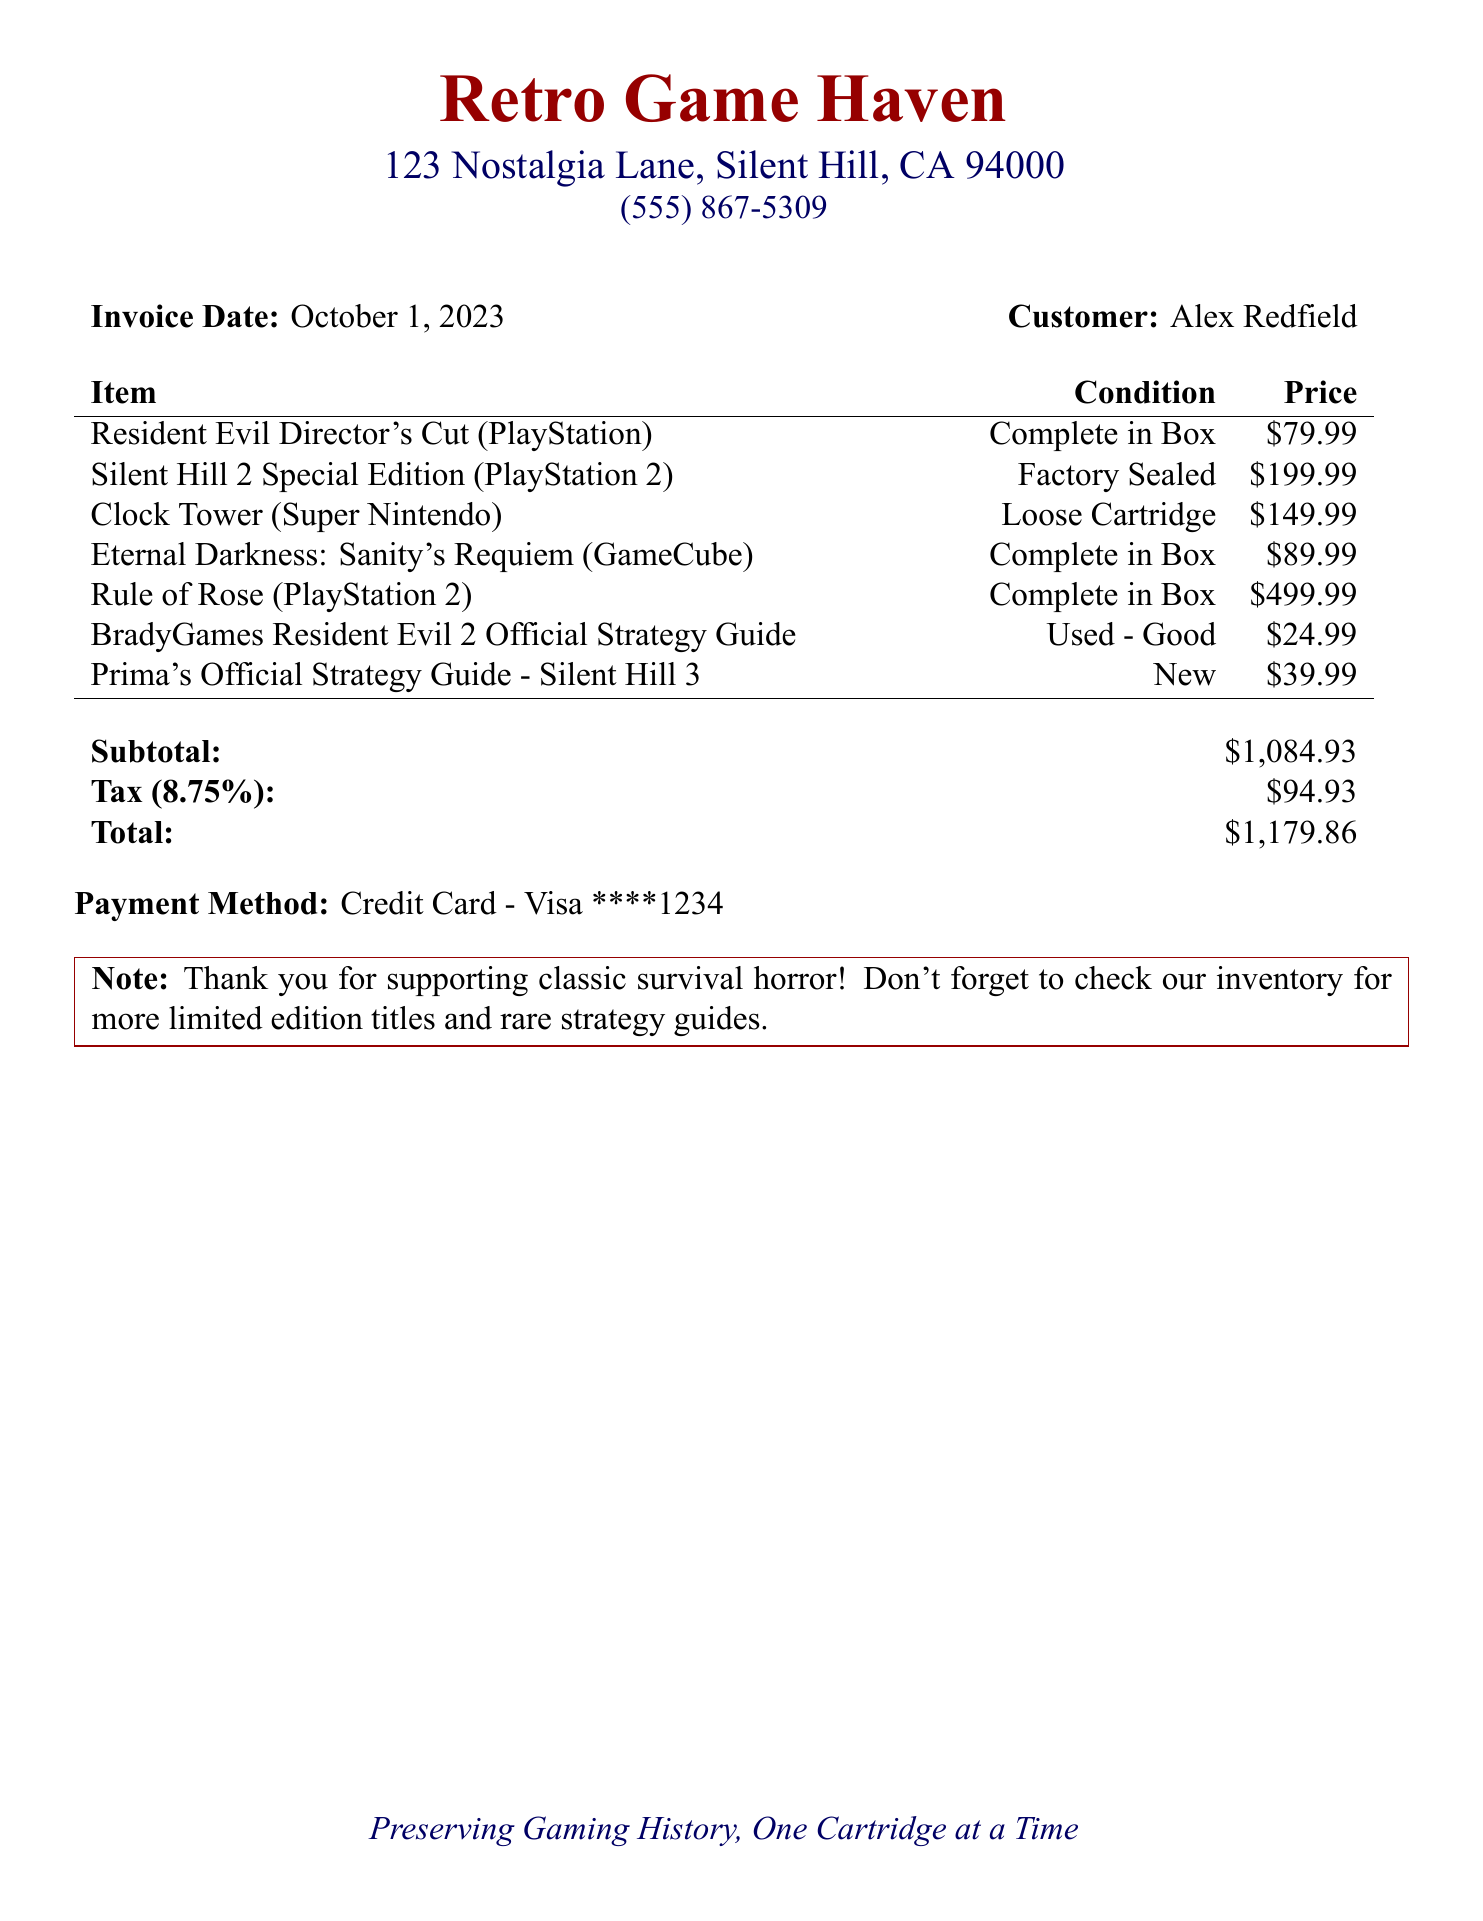What is the store name? The store name is clearly indicated at the top of the document.
Answer: Retro Game Haven Who is the customer? The customer's name is mentioned next to the invoice date.
Answer: Alex Redfield What is the subtotal amount? The subtotal is listed in the invoice, which summarizes the cost before tax.
Answer: $1,084.93 What payment method was used? The payment method is explicitly mentioned in the invoice details.
Answer: Credit Card - Visa ****1234 How much is the tax amount? The tax amount is specified in the invoice under the tax section.
Answer: $94.93 What is the condition of the Silent Hill 2 Special Edition? The condition of each game is listed next to its title.
Answer: Factory Sealed How many items were purchased in total? The invoice lists seven items purchased.
Answer: 7 What is the total amount due? The total amount is clearly noted at the end of the invoice, including all costs.
Answer: $1,179.86 What type of document is this? The document is specifically categorized in the header and overall structure.
Answer: Invoice 